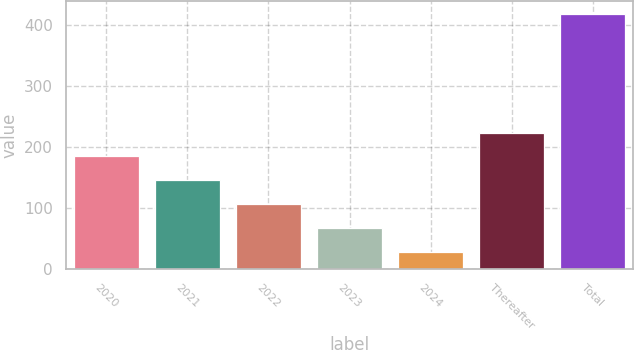<chart> <loc_0><loc_0><loc_500><loc_500><bar_chart><fcel>2020<fcel>2021<fcel>2022<fcel>2023<fcel>2024<fcel>Thereafter<fcel>Total<nl><fcel>184.36<fcel>145.42<fcel>106.48<fcel>67.54<fcel>28.6<fcel>223.3<fcel>418<nl></chart> 